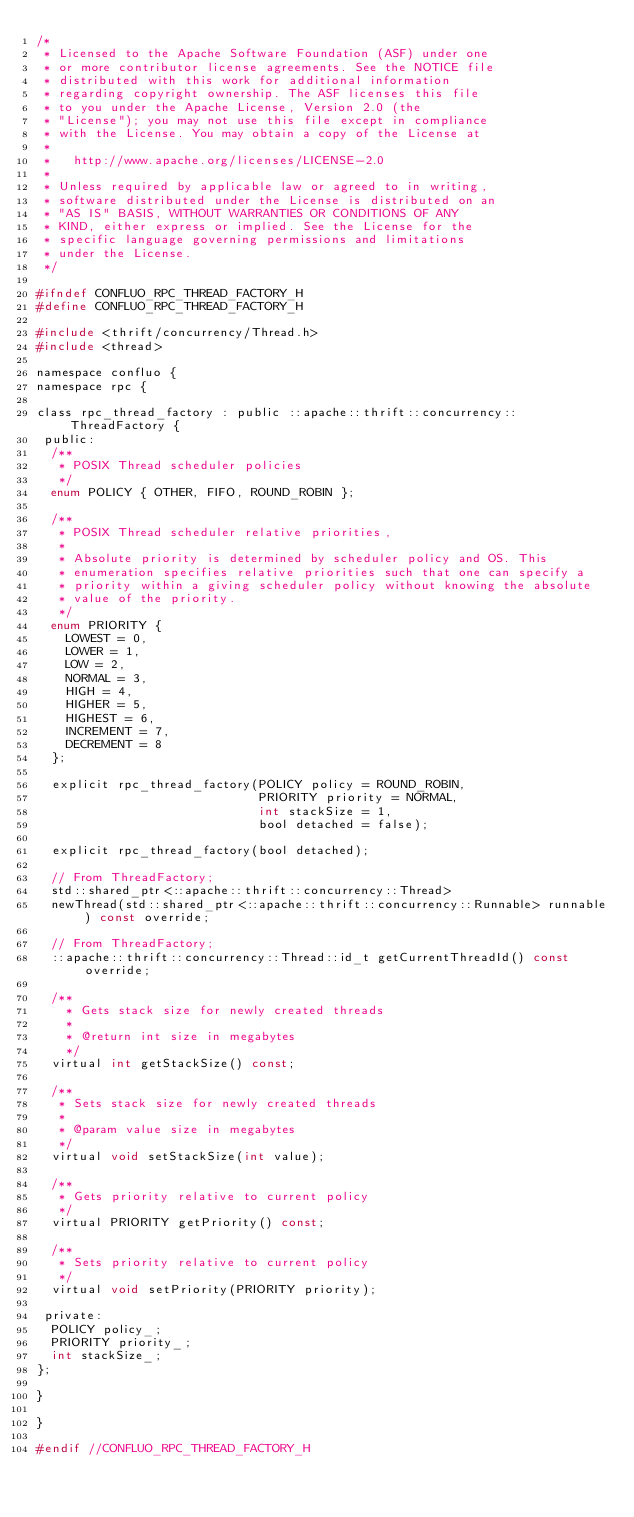Convert code to text. <code><loc_0><loc_0><loc_500><loc_500><_C_>/*
 * Licensed to the Apache Software Foundation (ASF) under one
 * or more contributor license agreements. See the NOTICE file
 * distributed with this work for additional information
 * regarding copyright ownership. The ASF licenses this file
 * to you under the Apache License, Version 2.0 (the
 * "License"); you may not use this file except in compliance
 * with the License. You may obtain a copy of the License at
 *
 *   http://www.apache.org/licenses/LICENSE-2.0
 *
 * Unless required by applicable law or agreed to in writing,
 * software distributed under the License is distributed on an
 * "AS IS" BASIS, WITHOUT WARRANTIES OR CONDITIONS OF ANY
 * KIND, either express or implied. See the License for the
 * specific language governing permissions and limitations
 * under the License.
 */

#ifndef CONFLUO_RPC_THREAD_FACTORY_H
#define CONFLUO_RPC_THREAD_FACTORY_H

#include <thrift/concurrency/Thread.h>
#include <thread>

namespace confluo {
namespace rpc {

class rpc_thread_factory : public ::apache::thrift::concurrency::ThreadFactory {
 public:
  /**
   * POSIX Thread scheduler policies
   */
  enum POLICY { OTHER, FIFO, ROUND_ROBIN };

  /**
   * POSIX Thread scheduler relative priorities,
   *
   * Absolute priority is determined by scheduler policy and OS. This
   * enumeration specifies relative priorities such that one can specify a
   * priority within a giving scheduler policy without knowing the absolute
   * value of the priority.
   */
  enum PRIORITY {
    LOWEST = 0,
    LOWER = 1,
    LOW = 2,
    NORMAL = 3,
    HIGH = 4,
    HIGHER = 5,
    HIGHEST = 6,
    INCREMENT = 7,
    DECREMENT = 8
  };

  explicit rpc_thread_factory(POLICY policy = ROUND_ROBIN,
                              PRIORITY priority = NORMAL,
                              int stackSize = 1,
                              bool detached = false);

  explicit rpc_thread_factory(bool detached);

  // From ThreadFactory;
  std::shared_ptr<::apache::thrift::concurrency::Thread>
  newThread(std::shared_ptr<::apache::thrift::concurrency::Runnable> runnable) const override;

  // From ThreadFactory;
  ::apache::thrift::concurrency::Thread::id_t getCurrentThreadId() const override;

  /**
    * Gets stack size for newly created threads
    *
    * @return int size in megabytes
    */
  virtual int getStackSize() const;

  /**
   * Sets stack size for newly created threads
   *
   * @param value size in megabytes
   */
  virtual void setStackSize(int value);

  /**
   * Gets priority relative to current policy
   */
  virtual PRIORITY getPriority() const;

  /**
   * Sets priority relative to current policy
   */
  virtual void setPriority(PRIORITY priority);

 private:
  POLICY policy_;
  PRIORITY priority_;
  int stackSize_;
};

}

}

#endif //CONFLUO_RPC_THREAD_FACTORY_H
</code> 